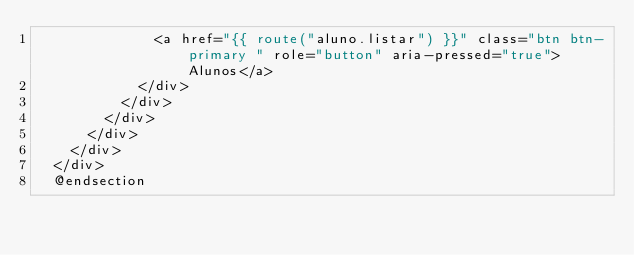<code> <loc_0><loc_0><loc_500><loc_500><_PHP_>              <a href="{{ route("aluno.listar") }}" class="btn btn-primary " role="button" aria-pressed="true">Alunos</a>
            </div>
          </div>
        </div>
      </div>
    </div>
  </div>
  @endsection
</code> 